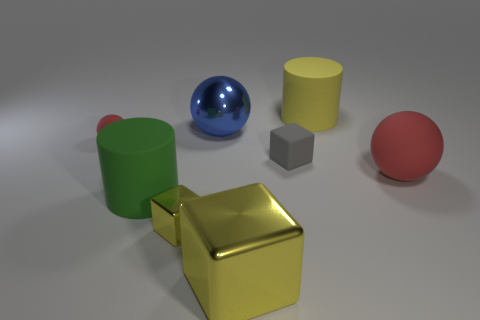Subtract all yellow cubes. How many were subtracted if there are1yellow cubes left? 1 Subtract all yellow shiny blocks. How many blocks are left? 1 Add 2 red matte objects. How many objects exist? 10 Subtract all blue spheres. How many spheres are left? 2 Subtract all spheres. How many objects are left? 5 Subtract all green cylinders. How many yellow blocks are left? 2 Subtract 2 blocks. How many blocks are left? 1 Subtract all brown cylinders. Subtract all green cubes. How many cylinders are left? 2 Subtract all tiny green shiny cylinders. Subtract all shiny objects. How many objects are left? 5 Add 8 small blocks. How many small blocks are left? 10 